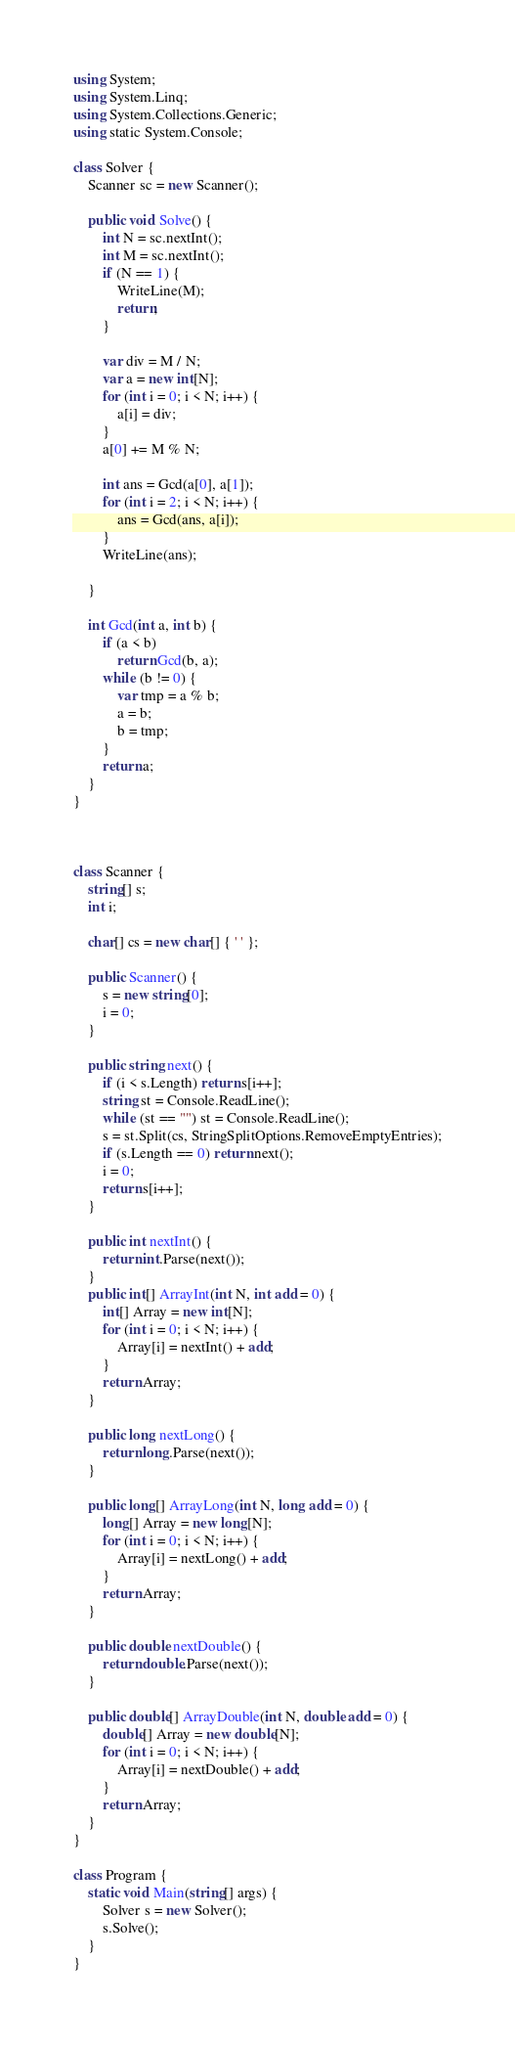Convert code to text. <code><loc_0><loc_0><loc_500><loc_500><_C#_>using System;
using System.Linq;
using System.Collections.Generic;
using static System.Console;

class Solver {
    Scanner sc = new Scanner();

    public void Solve() {
        int N = sc.nextInt();
        int M = sc.nextInt();
        if (N == 1) {
            WriteLine(M);
            return;
        }

        var div = M / N;
        var a = new int[N];
        for (int i = 0; i < N; i++) {
            a[i] = div;
        }
        a[0] += M % N;

        int ans = Gcd(a[0], a[1]);
        for (int i = 2; i < N; i++) {
            ans = Gcd(ans, a[i]);
        }
        WriteLine(ans);
       
    }

    int Gcd(int a, int b) {
        if (a < b)
            return Gcd(b, a);
        while (b != 0) {
            var tmp = a % b;
            a = b;
            b = tmp;
        }
        return a;
    }
}



class Scanner {
    string[] s;
    int i;

    char[] cs = new char[] { ' ' };

    public Scanner() {
        s = new string[0];
        i = 0;
    }

    public string next() {
        if (i < s.Length) return s[i++];
        string st = Console.ReadLine();
        while (st == "") st = Console.ReadLine();
        s = st.Split(cs, StringSplitOptions.RemoveEmptyEntries);
        if (s.Length == 0) return next();
        i = 0;
        return s[i++];
    }

    public int nextInt() {
        return int.Parse(next());
    }
    public int[] ArrayInt(int N, int add = 0) {
        int[] Array = new int[N];
        for (int i = 0; i < N; i++) {
            Array[i] = nextInt() + add;
        }
        return Array;
    }

    public long nextLong() {
        return long.Parse(next());
    }

    public long[] ArrayLong(int N, long add = 0) {
        long[] Array = new long[N];
        for (int i = 0; i < N; i++) {
            Array[i] = nextLong() + add;
        }
        return Array;
    }

    public double nextDouble() {
        return double.Parse(next());
    }

    public double[] ArrayDouble(int N, double add = 0) {
        double[] Array = new double[N];
        for (int i = 0; i < N; i++) {
            Array[i] = nextDouble() + add;
        }
        return Array;
    }
}

class Program {
    static void Main(string[] args) {
        Solver s = new Solver();
        s.Solve();
    }
}
</code> 